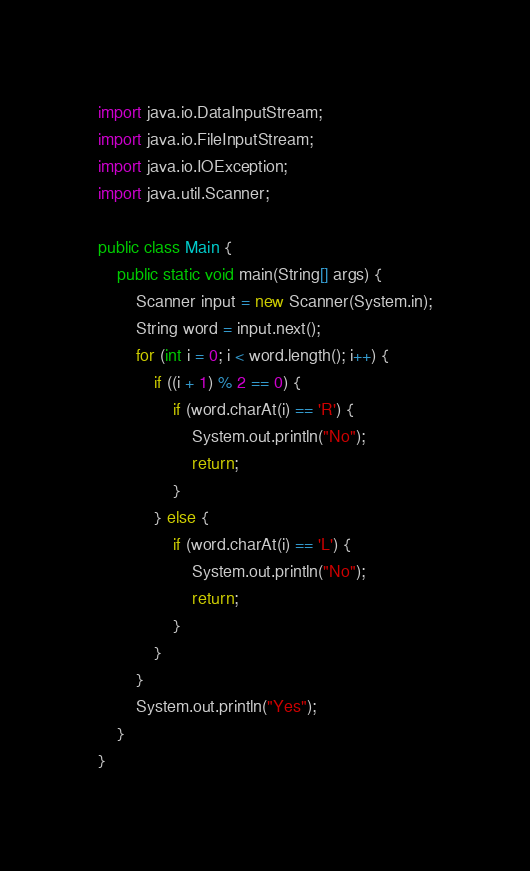<code> <loc_0><loc_0><loc_500><loc_500><_Java_>import java.io.DataInputStream;
import java.io.FileInputStream;
import java.io.IOException;
import java.util.Scanner;

public class Main {
    public static void main(String[] args) {
        Scanner input = new Scanner(System.in);
        String word = input.next();
        for (int i = 0; i < word.length(); i++) {
            if ((i + 1) % 2 == 0) {
                if (word.charAt(i) == 'R') {
                    System.out.println("No");
                    return;
                }
            } else {
                if (word.charAt(i) == 'L') {
                    System.out.println("No");
                    return;
                }
            }
        }
        System.out.println("Yes");
    }
}
</code> 